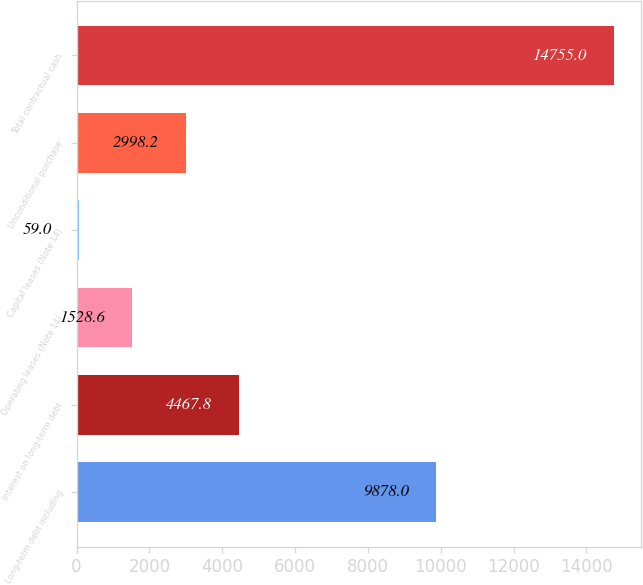Convert chart to OTSL. <chart><loc_0><loc_0><loc_500><loc_500><bar_chart><fcel>Long-term debt including<fcel>Interest on long-term debt<fcel>Operating leases (Note 14)<fcel>Capital leases (Note 14)<fcel>Unconditional purchase<fcel>Total contractual cash<nl><fcel>9878<fcel>4467.8<fcel>1528.6<fcel>59<fcel>2998.2<fcel>14755<nl></chart> 